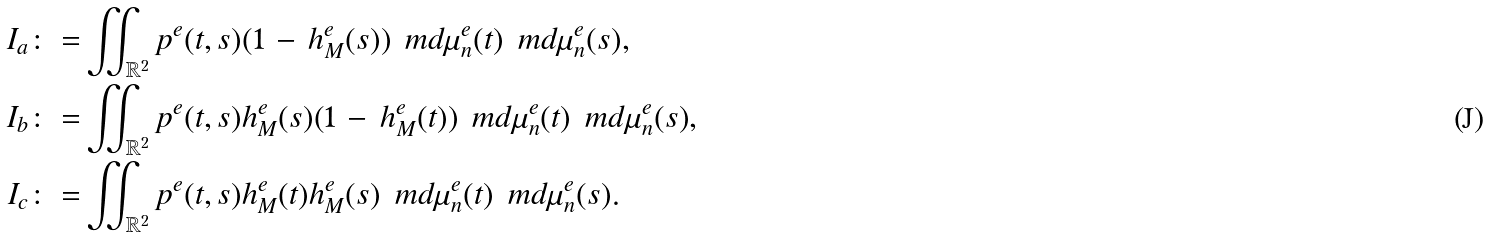<formula> <loc_0><loc_0><loc_500><loc_500>I _ { a } \colon = & \iint _ { \mathbb { R } ^ { 2 } } p ^ { e } ( t , s ) ( 1 \, - \, h _ { M } ^ { e } ( s ) ) \, \ m d \mu ^ { e } _ { n } ( t ) \, \ m d \mu _ { n } ^ { e } ( s ) , \\ I _ { b } \colon = & \iint _ { \mathbb { R } ^ { 2 } } p ^ { e } ( t , s ) h _ { M } ^ { e } ( s ) ( 1 \, - \, h _ { M } ^ { e } ( t ) ) \, \ m d \mu ^ { e } _ { n } ( t ) \, \ m d \mu _ { n } ^ { e } ( s ) , \\ I _ { c } \colon = & \iint _ { \mathbb { R } ^ { 2 } } p ^ { e } ( t , s ) h _ { M } ^ { e } ( t ) h _ { M } ^ { e } ( s ) \, \ m d \mu ^ { e } _ { n } ( t ) \, \ m d \mu _ { n } ^ { e } ( s ) .</formula> 